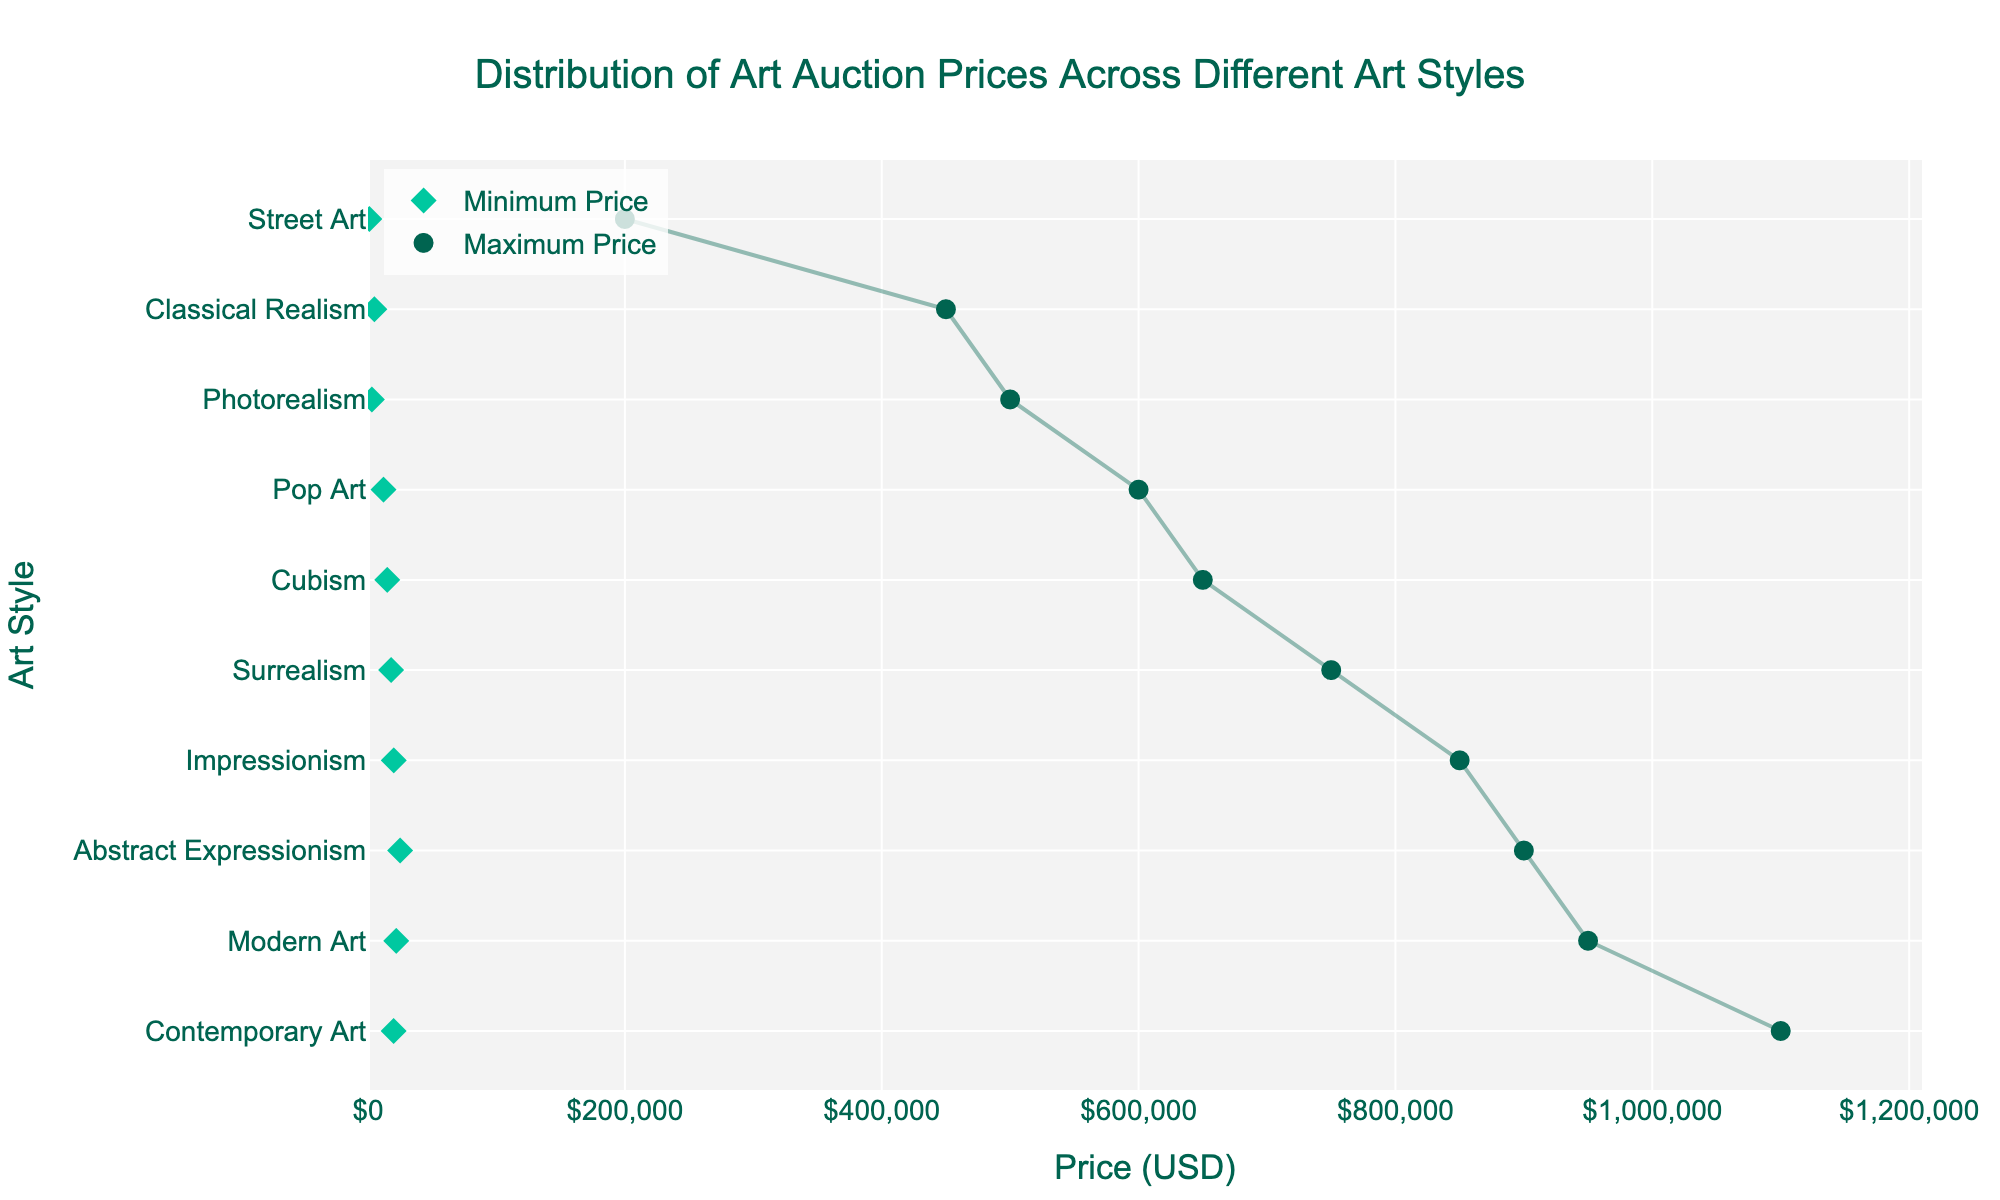What's the title of the figure? The title is shown at the top of the figure and usually summarizes what the figure represents.
Answer: Distribution of Art Auction Prices Across Different Art Styles Which art style has the highest maximum auction price? To find the highest maximum price, look at the value labeled with a circle (maximum price) farthest to the right on the x-axis.
Answer: Contemporary Art What's the difference between the minimum and maximum price of Pop Art? Locate the minimum and maximum prices for Pop Art marked by a diamond and a circle respectively. The minimum price is $12,000, and the maximum price is $600,000. Subtract the minimum from the maximum.
Answer: $588,000 How many art styles have a minimum price greater than $20,000? Identify the positions of diamond markers (minimum prices) greater than $20,000. Impressionism, Abstract Expressionism, and Contemporary Art fit this criterion.
Answer: 3 Which art style has the smallest range in auction prices? Find the art style where the distance between the minimum and maximum price markers is the shortest. Classical Realism ranges from $5,000 to $450,000, a range of $445,000. Compare this with others to confirm.
Answer: Classical Realism Are there any art styles with a minimum price equal to the maximum price of another art style? Compare the diamond and circle markers, specifically checking for equality between the minimum price of one art style and the maximum price of another.
Answer: No What's the median maximum price of all art styles? Sort the maximum prices and find the middle value. The sorted maximum prices are $200,000, $450,000, $500,000, $600,000, $650,000, $750,000, $850,000, $900,000, $950,000, and $1,100,000. The middle values are $650,000 and $750,000, and their average is $700,000.
Answer: $700,000 Which art style(s) have a minimum price below $10,000? Review the diamond markers (minimum prices) to identify those below $10,000. Street Art and Photorealism both have minimum prices below $10,000.
Answer: Street Art, Photorealism Is there any art style where the maximum price is less than $500,000? Identify circles (maximum prices) below $500,000. Classical Realism and Street Art both have maximum prices lower than $500,000.
Answer: Classical Realism, Street Art 